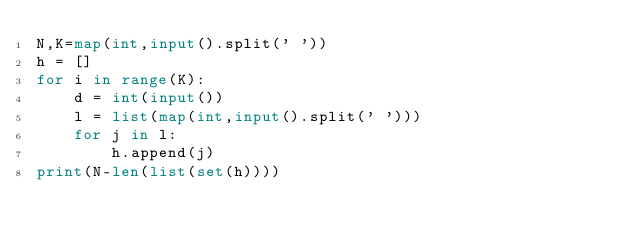Convert code to text. <code><loc_0><loc_0><loc_500><loc_500><_Python_>N,K=map(int,input().split(' '))
h = []
for i in range(K):
    d = int(input())
    l = list(map(int,input().split(' ')))
    for j in l:
        h.append(j)
print(N-len(list(set(h))))</code> 